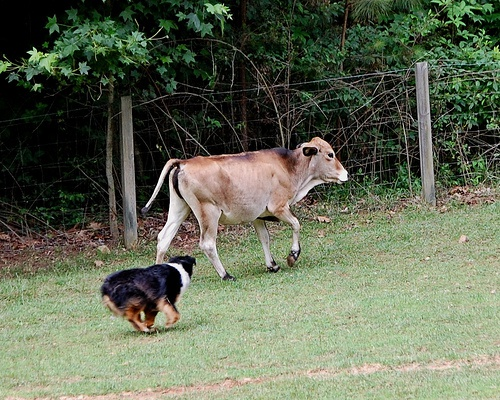Describe the objects in this image and their specific colors. I can see cow in black, darkgray, gray, and lightgray tones and dog in black, gray, darkgray, and maroon tones in this image. 